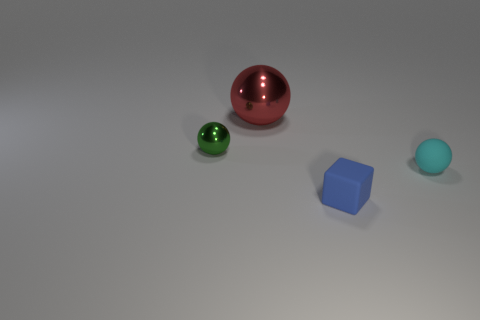Is there any other thing that is the same size as the red thing?
Provide a succinct answer. No. There is a metallic sphere that is in front of the big red object behind the tiny ball to the right of the blue rubber block; what is its size?
Your response must be concise. Small. What size is the cyan thing that is the same shape as the big red thing?
Your answer should be very brief. Small. There is a big red sphere; how many cyan objects are on the left side of it?
Give a very brief answer. 0. How many blue objects are either cubes or large metal spheres?
Your answer should be very brief. 1. There is a matte thing that is left of the small cyan rubber sphere that is right of the green metallic thing; what is its color?
Keep it short and to the point. Blue. What is the color of the matte thing on the right side of the tiny blue matte block?
Your response must be concise. Cyan. Is the size of the thing in front of the cyan rubber object the same as the large shiny thing?
Ensure brevity in your answer.  No. Is there a matte thing that has the same size as the cube?
Your answer should be very brief. Yes. How many other objects are the same shape as the small blue thing?
Your answer should be compact. 0. 